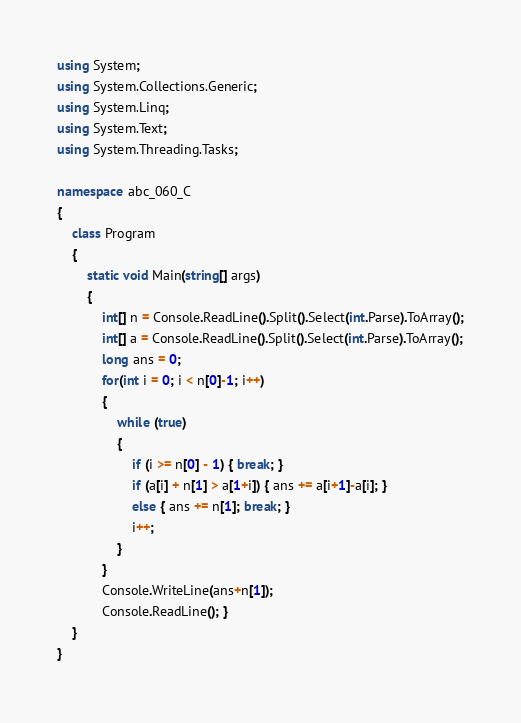Convert code to text. <code><loc_0><loc_0><loc_500><loc_500><_C#_>using System;
using System.Collections.Generic;
using System.Linq;
using System.Text;
using System.Threading.Tasks;

namespace abc_060_C
{
    class Program
    {
        static void Main(string[] args)
        {
            int[] n = Console.ReadLine().Split().Select(int.Parse).ToArray();
            int[] a = Console.ReadLine().Split().Select(int.Parse).ToArray();
            long ans = 0;
            for(int i = 0; i < n[0]-1; i++)
            {
                while (true)
                {
                    if (i >= n[0] - 1) { break; }
                    if (a[i] + n[1] > a[1+i]) { ans += a[i+1]-a[i]; }
                    else { ans += n[1]; break; }
                    i++;
                }
            }
            Console.WriteLine(ans+n[1]);
            Console.ReadLine(); }
    }
}
</code> 